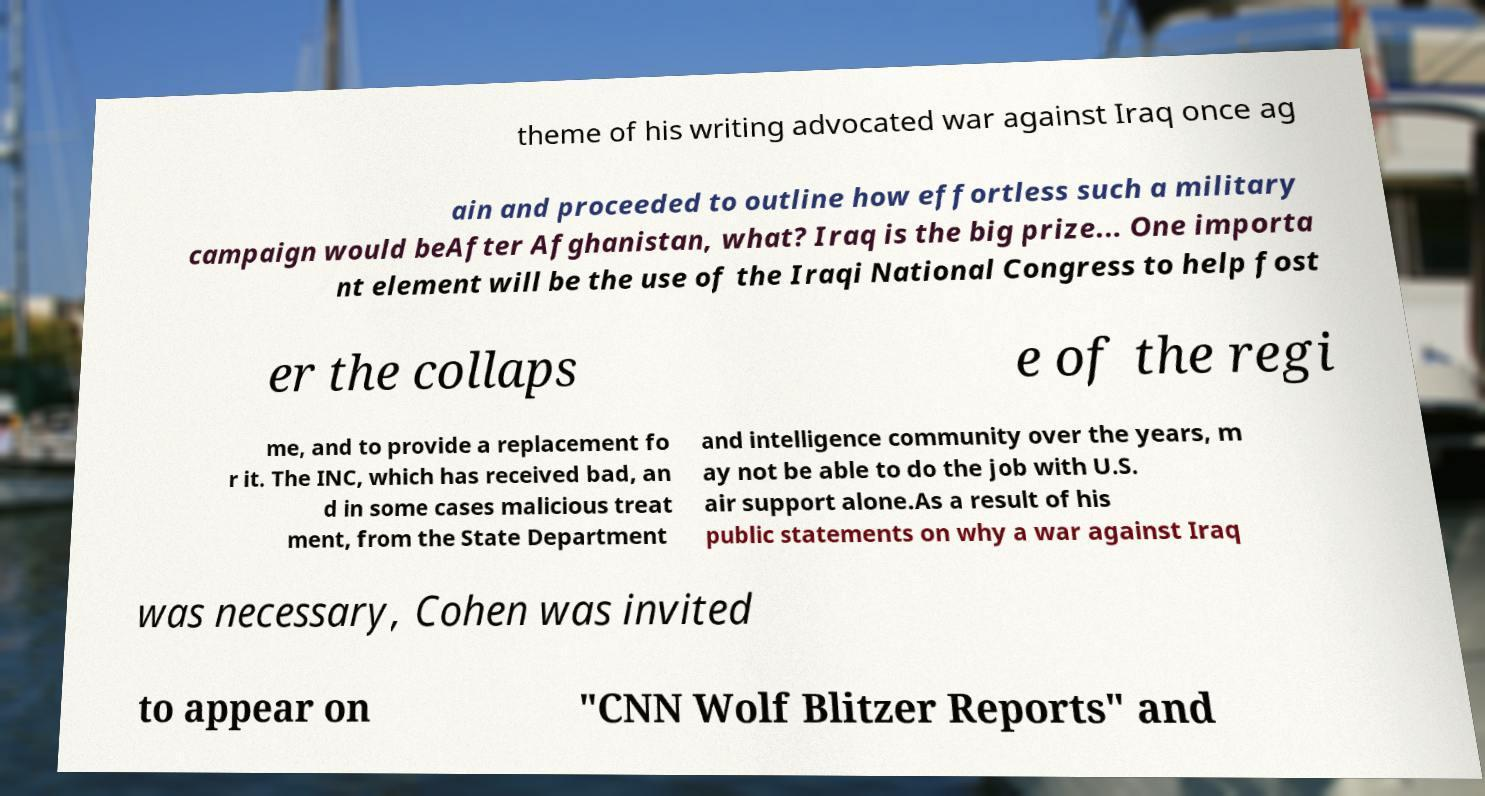Please identify and transcribe the text found in this image. theme of his writing advocated war against Iraq once ag ain and proceeded to outline how effortless such a military campaign would beAfter Afghanistan, what? Iraq is the big prize... One importa nt element will be the use of the Iraqi National Congress to help fost er the collaps e of the regi me, and to provide a replacement fo r it. The INC, which has received bad, an d in some cases malicious treat ment, from the State Department and intelligence community over the years, m ay not be able to do the job with U.S. air support alone.As a result of his public statements on why a war against Iraq was necessary, Cohen was invited to appear on "CNN Wolf Blitzer Reports" and 